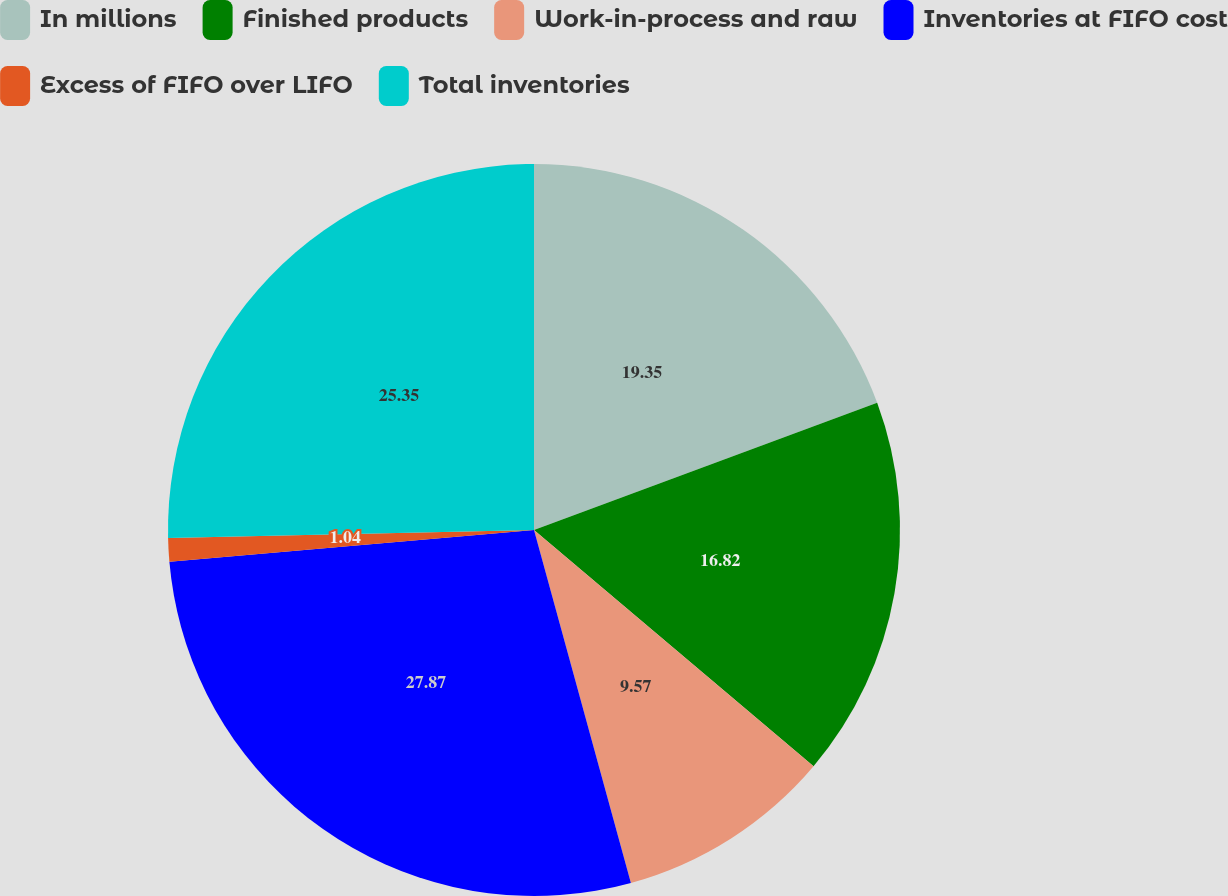Convert chart to OTSL. <chart><loc_0><loc_0><loc_500><loc_500><pie_chart><fcel>In millions<fcel>Finished products<fcel>Work-in-process and raw<fcel>Inventories at FIFO cost<fcel>Excess of FIFO over LIFO<fcel>Total inventories<nl><fcel>19.35%<fcel>16.82%<fcel>9.57%<fcel>27.88%<fcel>1.04%<fcel>25.35%<nl></chart> 